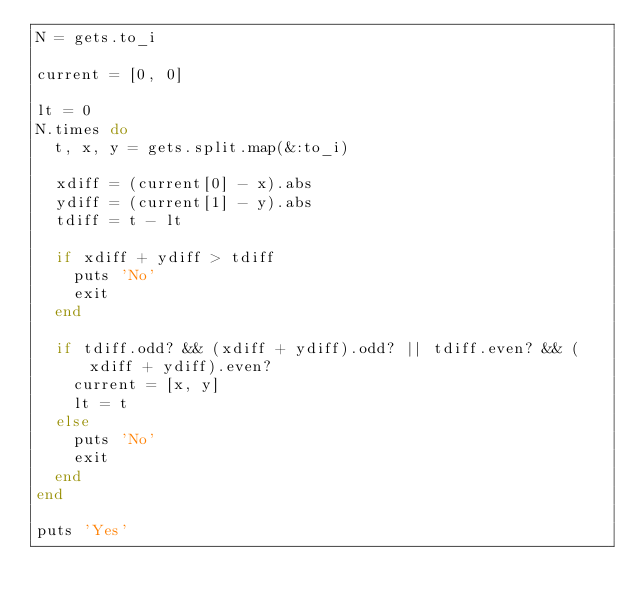Convert code to text. <code><loc_0><loc_0><loc_500><loc_500><_Ruby_>N = gets.to_i

current = [0, 0]

lt = 0
N.times do
  t, x, y = gets.split.map(&:to_i)

  xdiff = (current[0] - x).abs
  ydiff = (current[1] - y).abs
  tdiff = t - lt

  if xdiff + ydiff > tdiff
    puts 'No'
    exit
  end

  if tdiff.odd? && (xdiff + ydiff).odd? || tdiff.even? && (xdiff + ydiff).even?
    current = [x, y]
    lt = t
  else
    puts 'No'
    exit
  end
end

puts 'Yes'</code> 